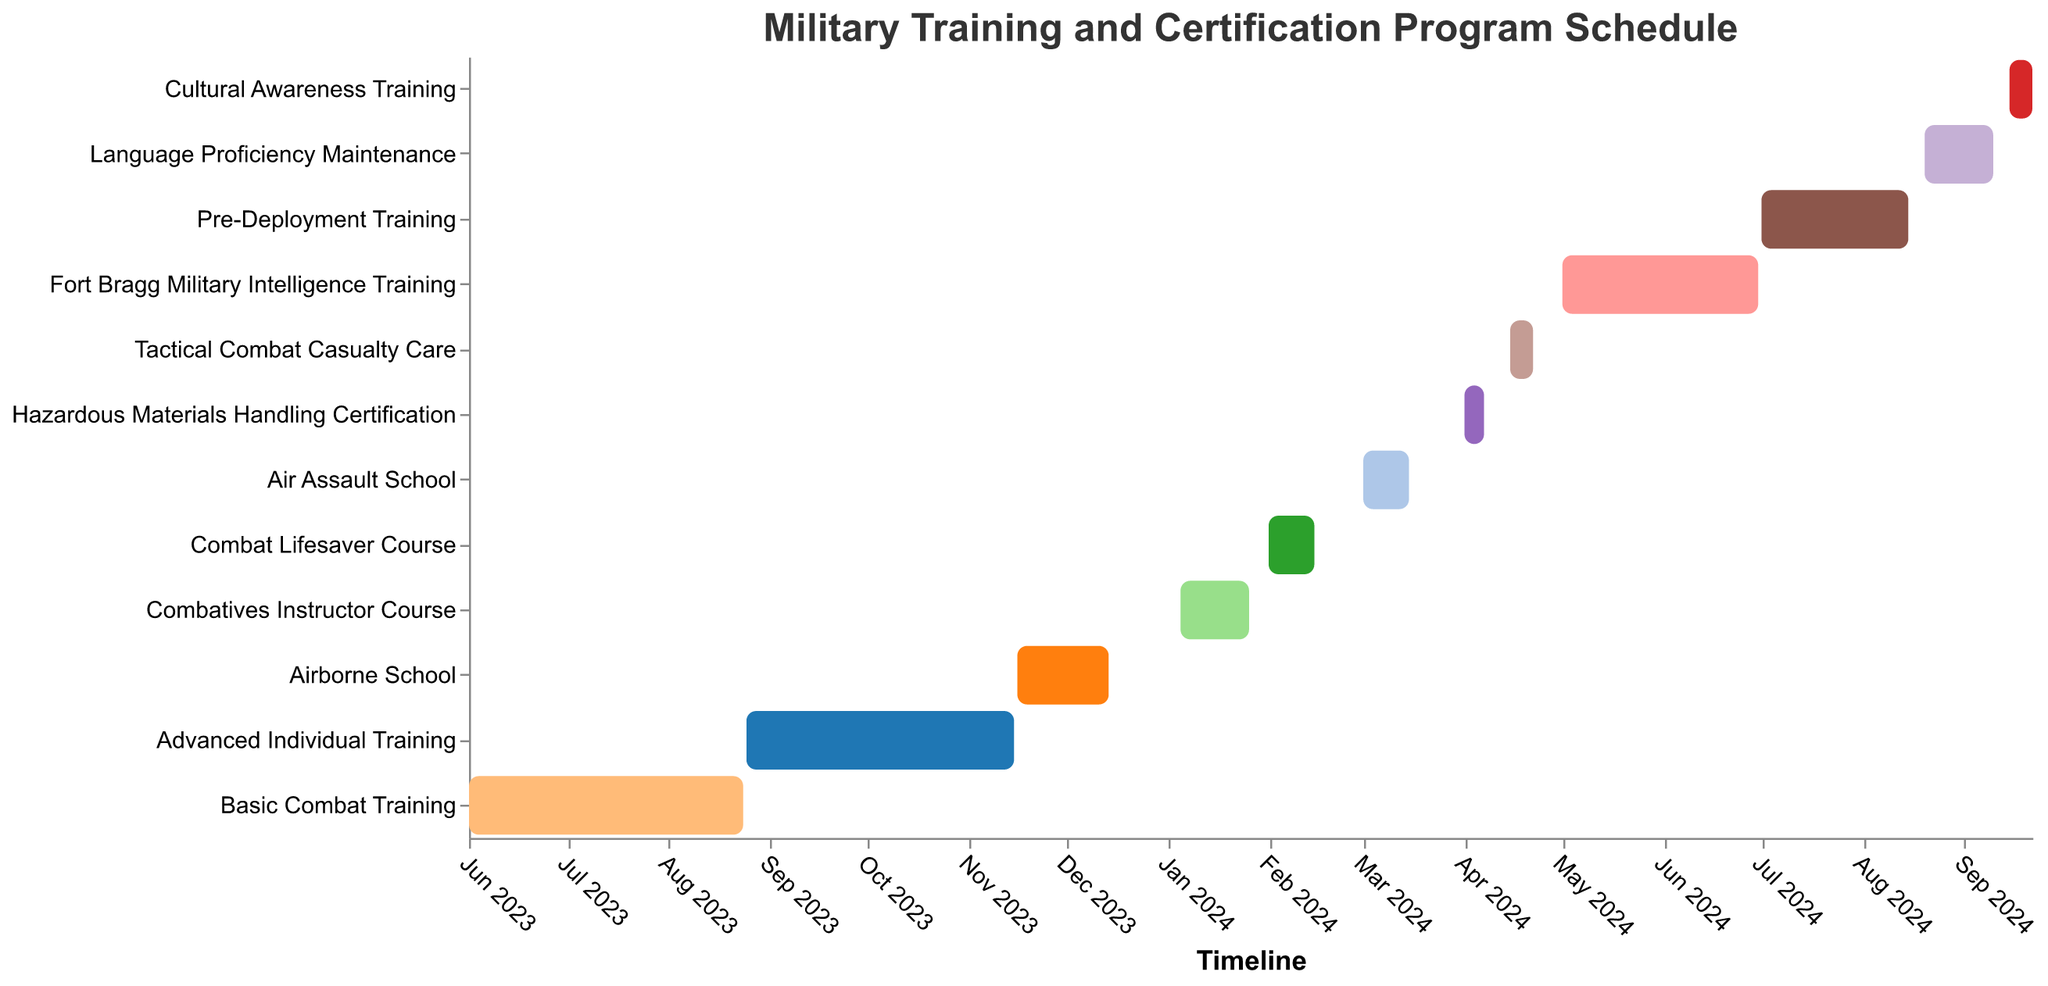How many tasks are listed in the training and certification program schedule? Count the number of different tasks from the data in the Gantt Chart.
Answer: 12 Which task has the longest duration? Compare the start and end dates of each task to see which one spans the most days.
Answer: Fort Bragg Military Intelligence Training When does the Combat Lifesaver Course start and end? Refer to the chart's bar labeled "Combat Lifesaver Course" and observe the start and end points.
Answer: February 1, 2024 - February 15, 2024 Which two courses follow the Advanced Individual Training? Look at the Gantt Chart and find the immediate successive courses after Advanced Individual Training.
Answer: Airborne School and Combatives Instructor Course How long does the Basic Combat Training last? Calculate the number of days from the start to the end date of Basic Combat Training.
Answer: 85 days What is the total duration of all training and certification programs, assuming they are done sequentially? Calculate the total duration by summing up the duration of each task. This includes durations from June 1, 2023, to September 22, 2024.
Answer: 479 days Which tasks are scheduled to begin in April 2024? Look for tasks that have start dates in April 2024 on the Gantt Chart.
Answer: Hazardous Materials Handling Certification and Tactical Combat Casualty Care What is the gap between the end of Airborne School and the start of Combatives Instructor Course? Calculate the difference in days between December 14, 2023 (end of Airborne School) and January 5, 2024 (start of Combatives Instructor Course).
Answer: 22 days Which task is scheduled right before the Pre-Deployment Training? Identify the task that ends just before the start of Pre-Deployment Training on the Gantt Chart.
Answer: Fort Bragg Military Intelligence Training Are there any tasks that overlap during April 2024? Check if any bars in April 2024 overlap on the timeline.
Answer: No 